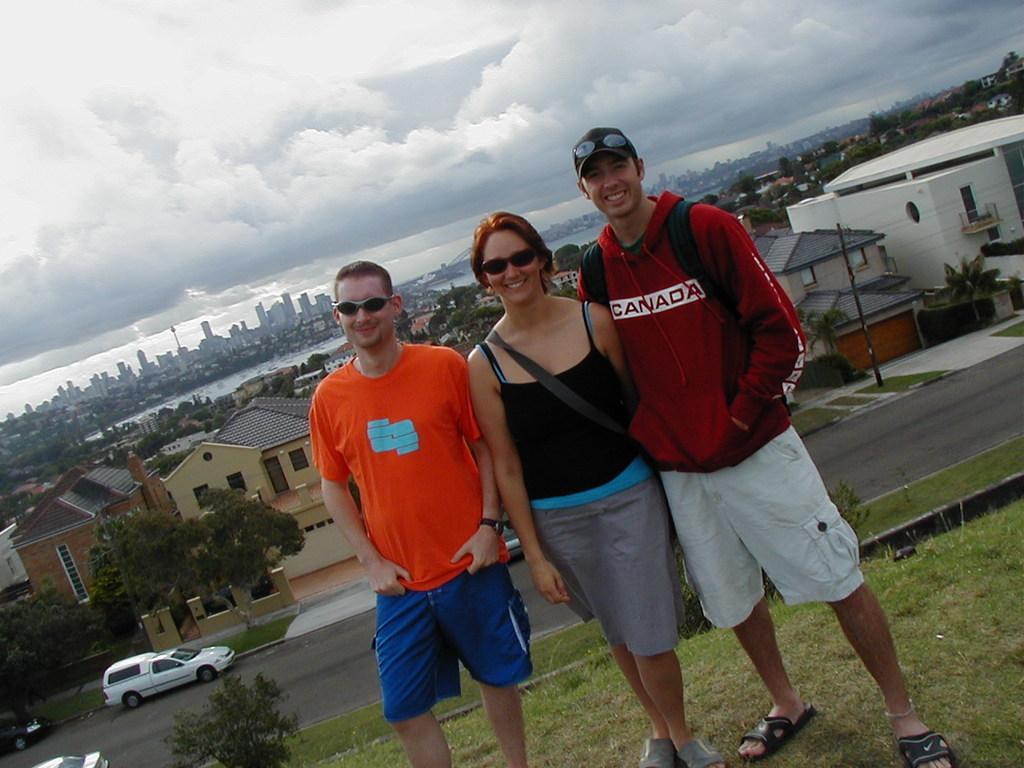Can you describe this image briefly? In this picture we can see three people wearing goggles and smiling. We can see some grass and plants on the ground. There are a few vehicles visible on the road. We can see a few houses and other objects in the background. Sky is cloudy. 